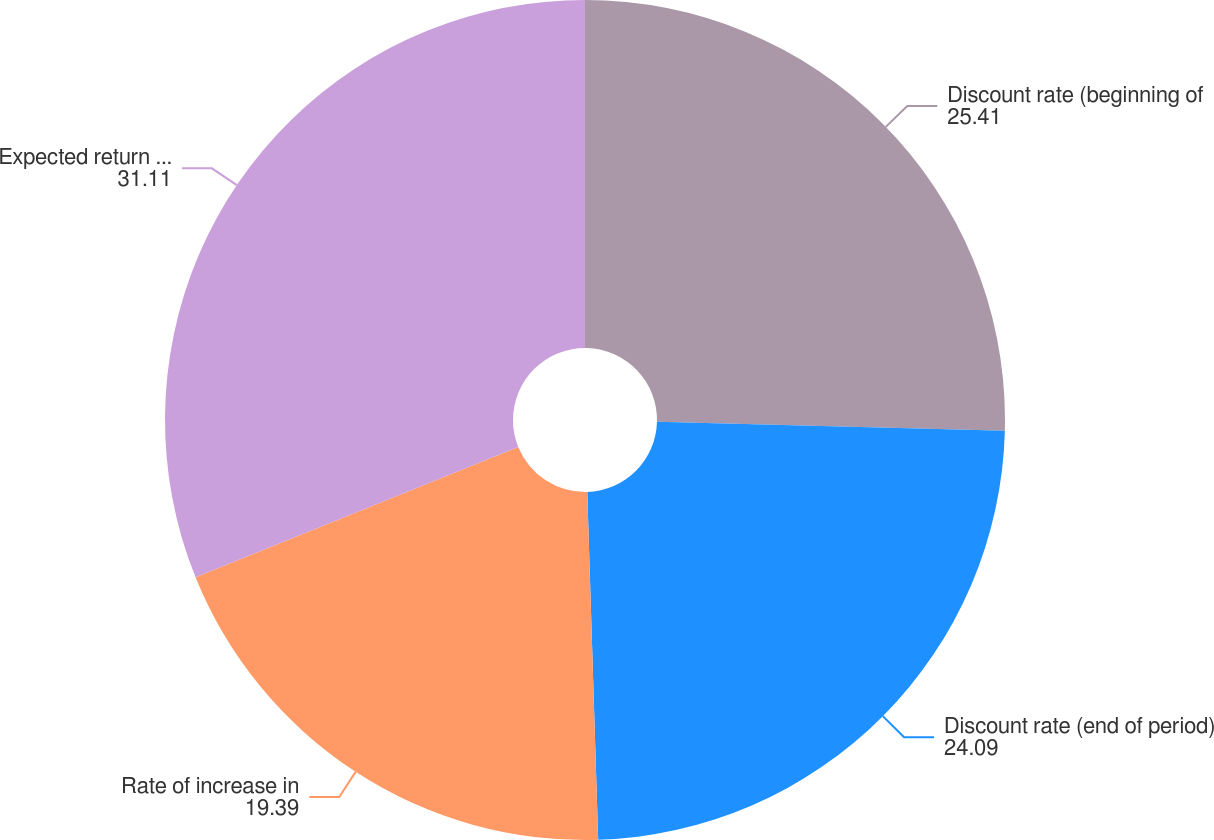Convert chart. <chart><loc_0><loc_0><loc_500><loc_500><pie_chart><fcel>Discount rate (beginning of<fcel>Discount rate (end of period)<fcel>Rate of increase in<fcel>Expected return on plan assets<nl><fcel>25.41%<fcel>24.09%<fcel>19.39%<fcel>31.11%<nl></chart> 